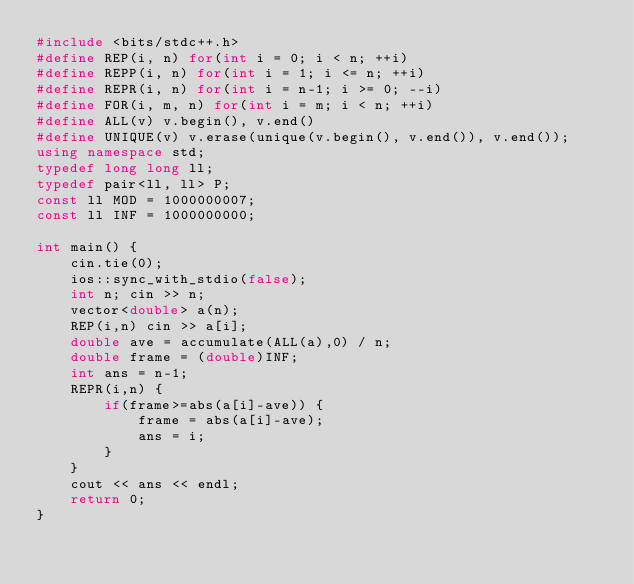Convert code to text. <code><loc_0><loc_0><loc_500><loc_500><_C++_>#include <bits/stdc++.h>
#define REP(i, n) for(int i = 0; i < n; ++i)
#define REPP(i, n) for(int i = 1; i <= n; ++i)
#define REPR(i, n) for(int i = n-1; i >= 0; --i)
#define FOR(i, m, n) for(int i = m; i < n; ++i)
#define ALL(v) v.begin(), v.end()
#define UNIQUE(v) v.erase(unique(v.begin(), v.end()), v.end());
using namespace std;
typedef long long ll;
typedef pair<ll, ll> P;
const ll MOD = 1000000007;
const ll INF = 1000000000;

int main() {
    cin.tie(0);
    ios::sync_with_stdio(false);
    int n; cin >> n;
    vector<double> a(n);
    REP(i,n) cin >> a[i];
    double ave = accumulate(ALL(a),0) / n;
    double frame = (double)INF;
    int ans = n-1;
    REPR(i,n) {
        if(frame>=abs(a[i]-ave)) {
            frame = abs(a[i]-ave);
            ans = i;
        }
    }
    cout << ans << endl;
    return 0;
}</code> 